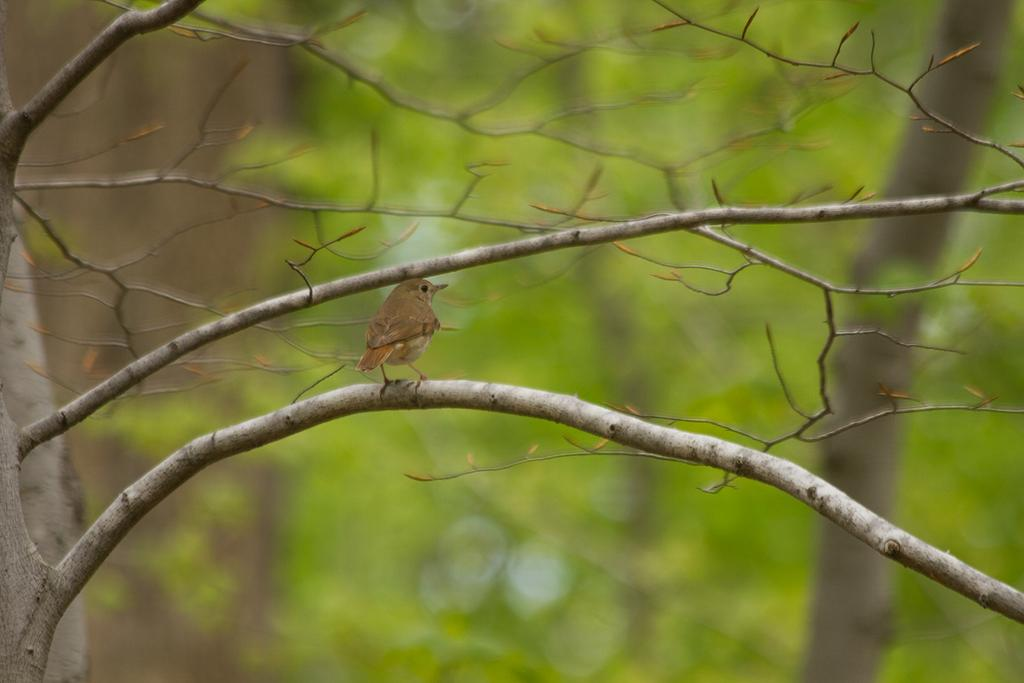What type of animal can be seen in the image? There is a bird in the image. Where is the bird located? The bird is on a stem in the image. What else can be seen in the image besides the bird? There are tree trunks in the image. What type of furniture is visible in the image? There is no furniture present in the image. What letter does the bird represent in the image? The image does not assign any letters to the bird or any other elements. 